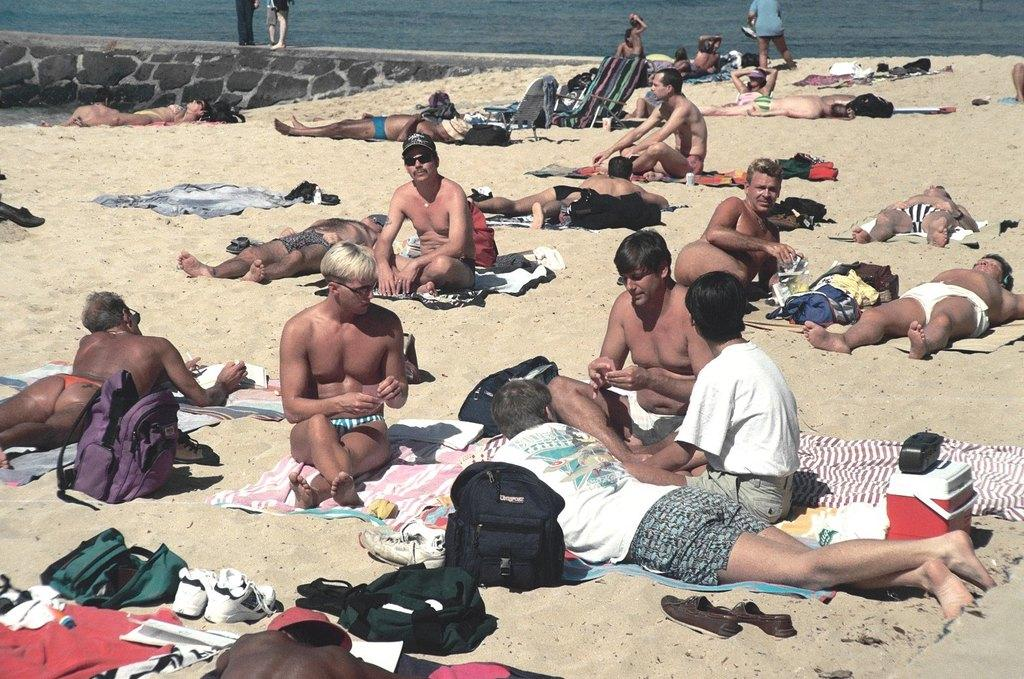What are the people in the image doing? There is a group of persons sitting on the ground in the image. What objects can be seen near the people? Bags and shoes are placed on the ground in the foreground. What can be seen in the background of the image? There is water visible in the background. What type of pipe can be seen in the image? There is no pipe present in the image. Can you see any cows in the image? No, there are no cows visible in the image. 